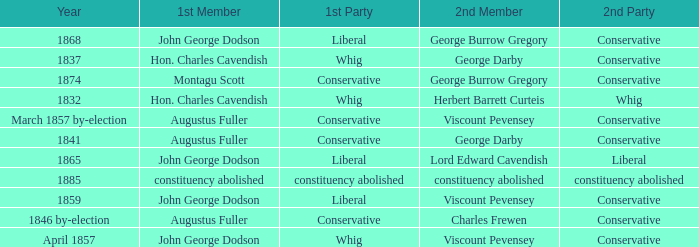In 1837, who was the 2nd member who's 2nd party was conservative. George Darby. 